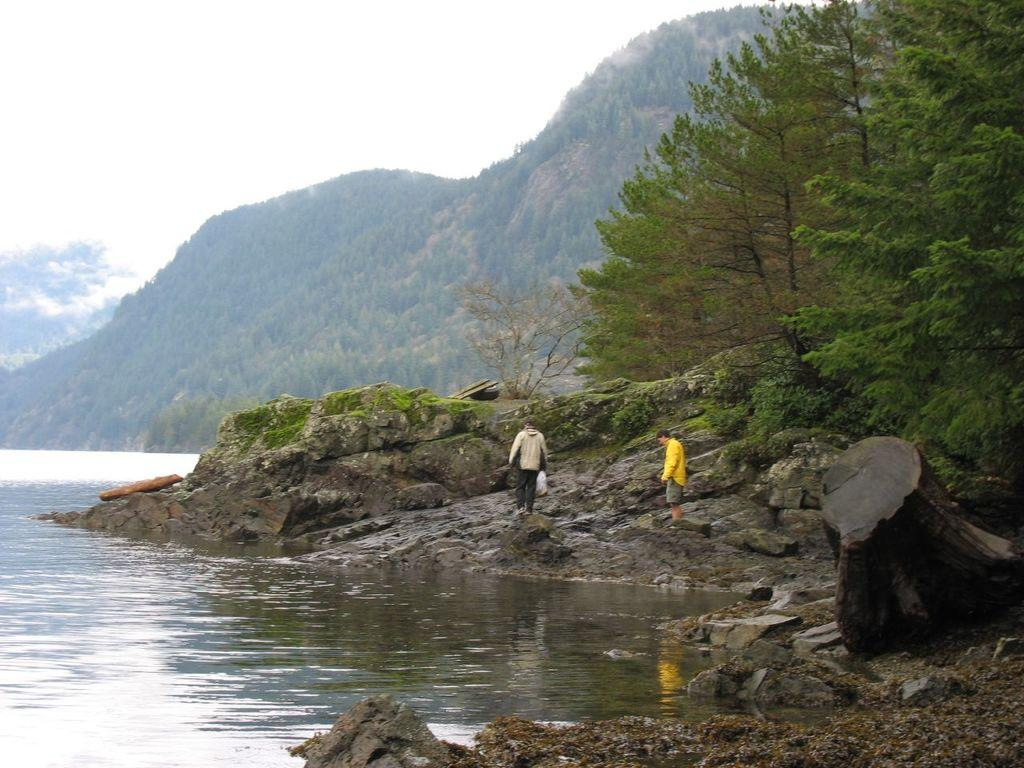What are the persons in the image standing on? The persons in the image are standing on rocks. What type of landscape can be seen in the image? Hills are visible in the image, along with trees and water. What is visible in the sky in the image? The sky is visible in the image, and clouds are present. What type of robin can be seen perched on the person's feet in the image? There is no robin present in the image; the persons' feet are not mentioned in the provided facts. 